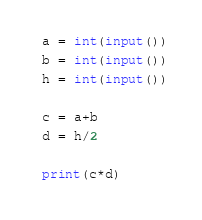Convert code to text. <code><loc_0><loc_0><loc_500><loc_500><_Python_>a = int(input())
b = int(input())
h = int(input())

c = a+b
d = h/2

print(c*d)</code> 